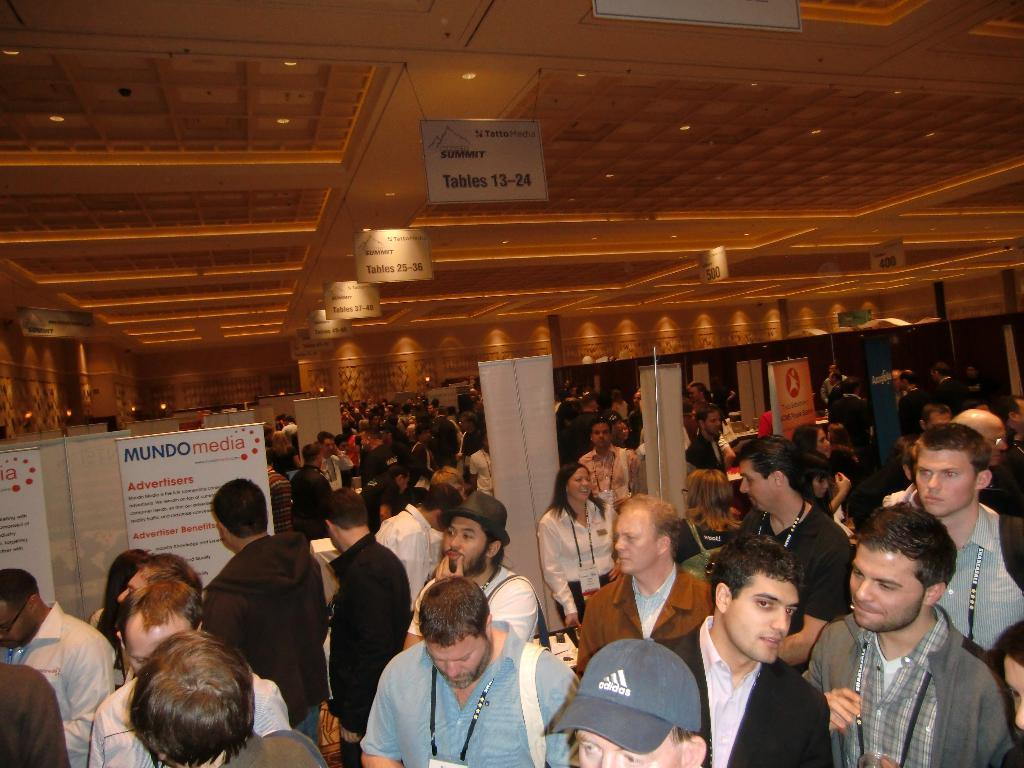What can be seen in the image involving people? There are people standing in the image. What is present between the people? There are banners between the people. What part of the room or space can be seen above the people? There is a ceiling visible in the image. What is hanging from the ceiling? There are boards hanging from the ceiling. How many doors can be seen in the image? There is no door visible in the image. What type of light source is present in the image? There is no specific light source mentioned in the provided facts, so it cannot be determined from the image. 